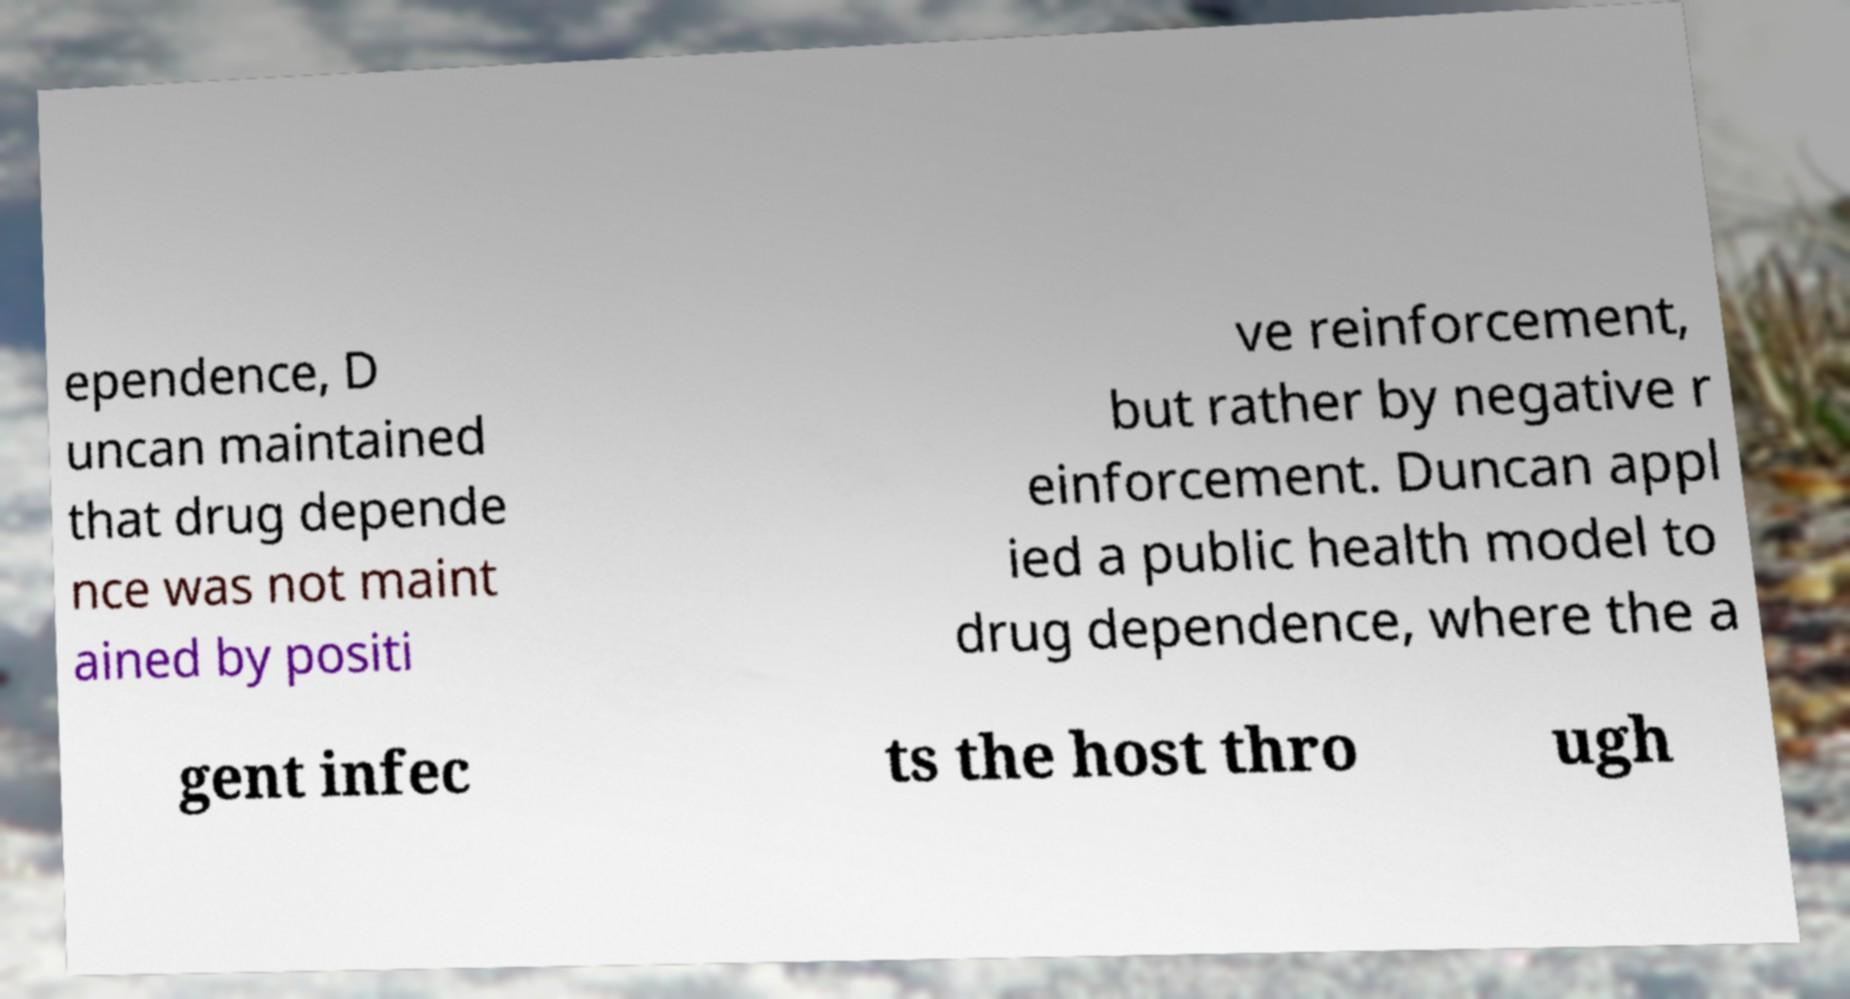Please identify and transcribe the text found in this image. ependence, D uncan maintained that drug depende nce was not maint ained by positi ve reinforcement, but rather by negative r einforcement. Duncan appl ied a public health model to drug dependence, where the a gent infec ts the host thro ugh 